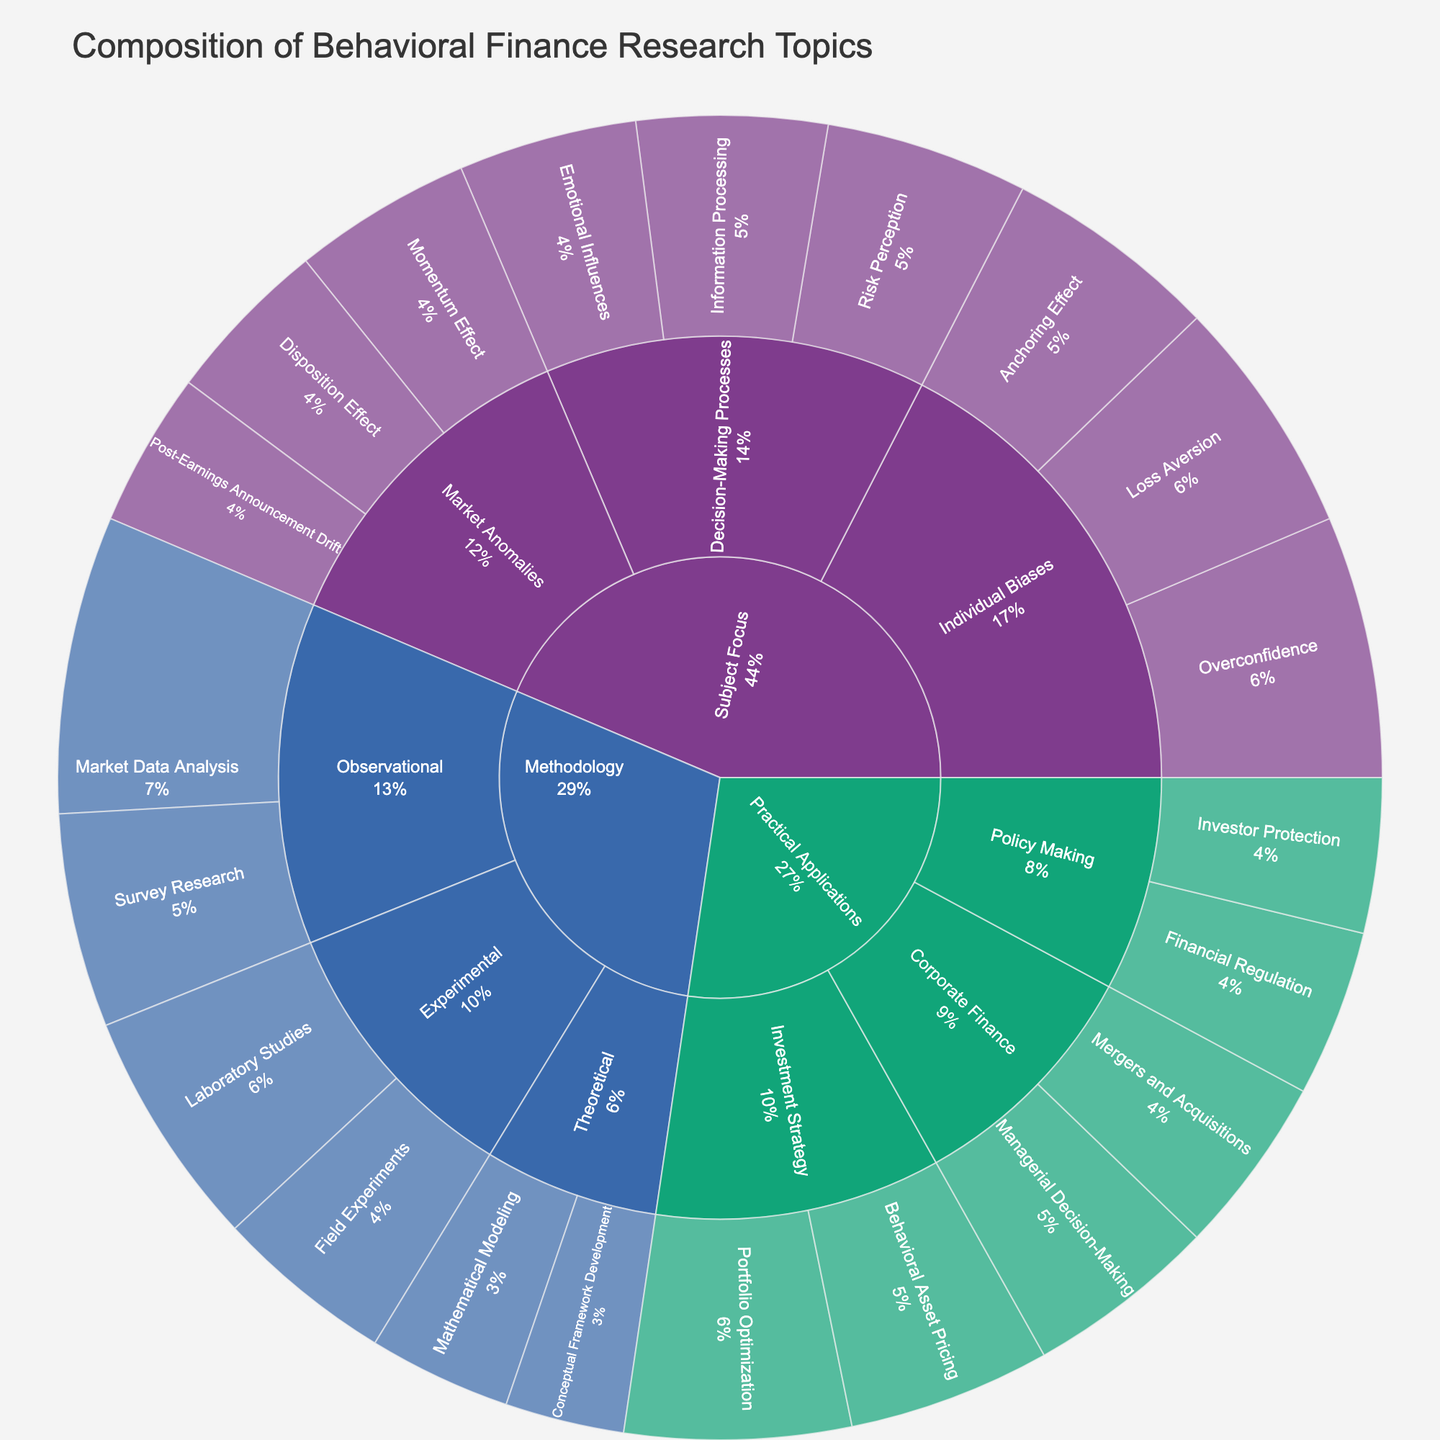What is the title of the sunburst plot? The title of the sunburst plot is always visible at the top of the figure.
Answer: Composition of Behavioral Finance Research Topics Which category has the highest total value? Observe the sizes of the sections corresponding to each main category (Methodology, Subject Focus, Practical Applications). The largest section represents the highest total value.
Answer: Subject Focus How many subcategories are there under Methodology? Count the number of distinct subcategories within Methodology's section in the sunburst plot.
Answer: 3 subcategories What is the combined value of all experimental methodologies? Sum the values associated with Laboratory Studies and Field Experiments under the Experimental subcategory. Specifically, 20 (Laboratory Studies) + 15 (Field Experiments).
Answer: 35 Which subcategory in Subject Focus has the smallest value? Identify the subcategories under Subject Focus and compare their values to find the smallest one.
Answer: Post-Earnings Announcement Drift Compare the values of Portfolio Optimization and Behavioral Asset Pricing. Which one is higher? Locate these two subsubcategories under Investment Strategy in Practical Applications and compare their values directly.
Answer: Portfolio Optimization What is the total value associated with Corporate Finance subcategories? Sum the values of the subsubcategories Managerial Decision-Making and Mergers and Acquisitions under Corporate Finance in Practical Applications: 16 (Managerial Decision-Making) + 15 (Mergers and Acquisitions).
Answer: 31 What percentage of the total does Market Data Analysis contribute to Methodology? Calculate the total for Methodology, and then find the percentage of Market Data Analysis's value (25) out of the total: (20 + 15 + 25 + 18 + 12 + 10). Total = 100, therefore 25/100 = 25%.
Answer: 25% Which category shows the greatest diversity in subcategories by totaling unique subcategories and subsubcategories? Count the number of subcategories and subsubcategories within each main category.
Answer: Subject Focus What is the value of Disposition Effect and how does it compare to Emotional Influences? Identify the values of Disposition Effect (14) and Emotional Influences (15) and compare them to see which is higher.
Answer: Emotional Influences is higher 